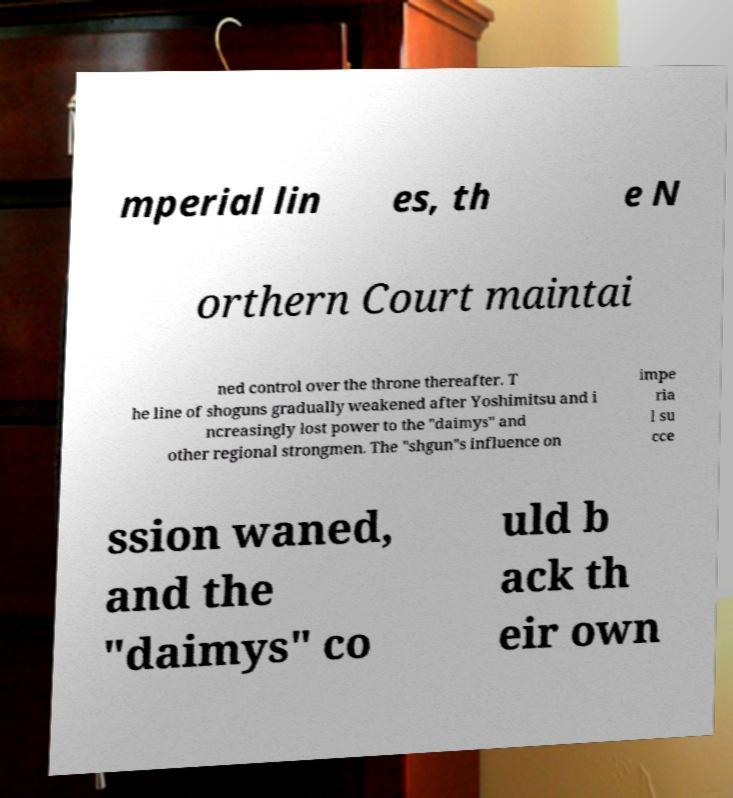Can you read and provide the text displayed in the image?This photo seems to have some interesting text. Can you extract and type it out for me? mperial lin es, th e N orthern Court maintai ned control over the throne thereafter. T he line of shoguns gradually weakened after Yoshimitsu and i ncreasingly lost power to the "daimys" and other regional strongmen. The "shgun"s influence on impe ria l su cce ssion waned, and the "daimys" co uld b ack th eir own 